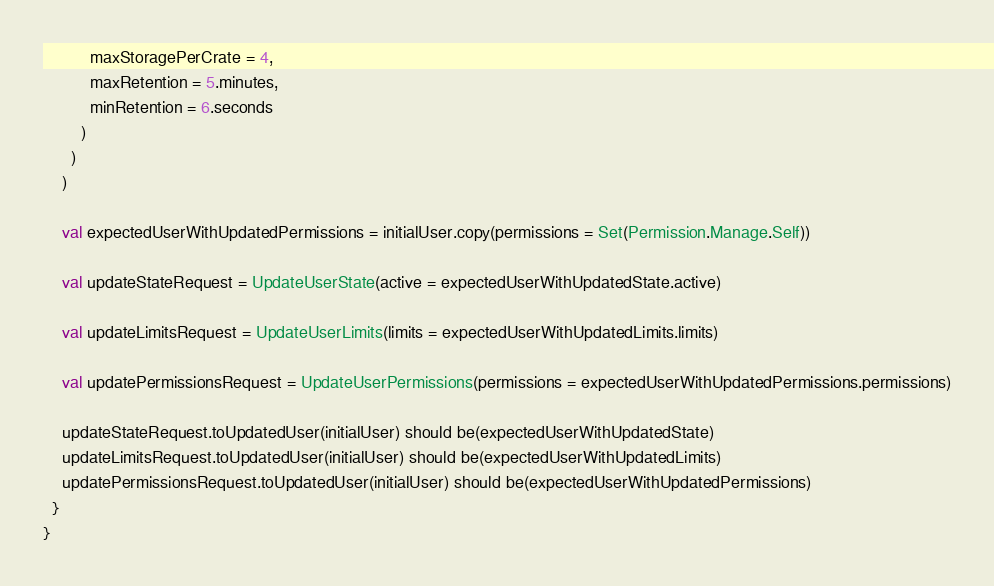<code> <loc_0><loc_0><loc_500><loc_500><_Scala_>          maxStoragePerCrate = 4,
          maxRetention = 5.minutes,
          minRetention = 6.seconds
        )
      )
    )

    val expectedUserWithUpdatedPermissions = initialUser.copy(permissions = Set(Permission.Manage.Self))

    val updateStateRequest = UpdateUserState(active = expectedUserWithUpdatedState.active)

    val updateLimitsRequest = UpdateUserLimits(limits = expectedUserWithUpdatedLimits.limits)

    val updatePermissionsRequest = UpdateUserPermissions(permissions = expectedUserWithUpdatedPermissions.permissions)

    updateStateRequest.toUpdatedUser(initialUser) should be(expectedUserWithUpdatedState)
    updateLimitsRequest.toUpdatedUser(initialUser) should be(expectedUserWithUpdatedLimits)
    updatePermissionsRequest.toUpdatedUser(initialUser) should be(expectedUserWithUpdatedPermissions)
  }
}
</code> 